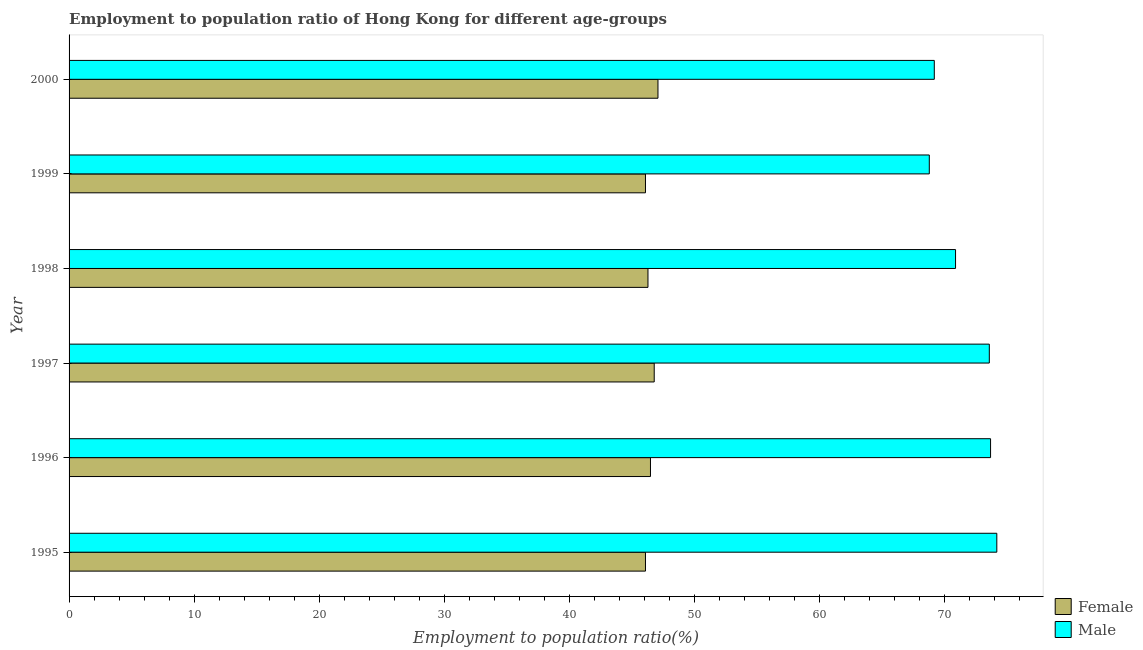How many different coloured bars are there?
Offer a very short reply. 2. How many groups of bars are there?
Keep it short and to the point. 6. Are the number of bars on each tick of the Y-axis equal?
Provide a short and direct response. Yes. How many bars are there on the 5th tick from the top?
Provide a succinct answer. 2. In how many cases, is the number of bars for a given year not equal to the number of legend labels?
Provide a succinct answer. 0. What is the employment to population ratio(female) in 1998?
Your response must be concise. 46.3. Across all years, what is the maximum employment to population ratio(male)?
Ensure brevity in your answer.  74.2. Across all years, what is the minimum employment to population ratio(female)?
Provide a short and direct response. 46.1. In which year was the employment to population ratio(female) maximum?
Provide a succinct answer. 2000. In which year was the employment to population ratio(female) minimum?
Make the answer very short. 1995. What is the total employment to population ratio(female) in the graph?
Keep it short and to the point. 278.9. What is the difference between the employment to population ratio(male) in 1997 and that in 1998?
Provide a short and direct response. 2.7. What is the difference between the employment to population ratio(male) in 1997 and the employment to population ratio(female) in 1996?
Make the answer very short. 27.1. What is the average employment to population ratio(female) per year?
Keep it short and to the point. 46.48. In the year 1998, what is the difference between the employment to population ratio(female) and employment to population ratio(male)?
Your answer should be compact. -24.6. Is the employment to population ratio(female) in 1998 less than that in 2000?
Your response must be concise. Yes. Is the difference between the employment to population ratio(female) in 1995 and 1998 greater than the difference between the employment to population ratio(male) in 1995 and 1998?
Your response must be concise. No. What is the difference between the highest and the second highest employment to population ratio(male)?
Your answer should be compact. 0.5. What is the difference between the highest and the lowest employment to population ratio(male)?
Provide a succinct answer. 5.4. Is the sum of the employment to population ratio(female) in 1996 and 2000 greater than the maximum employment to population ratio(male) across all years?
Offer a very short reply. Yes. What does the 1st bar from the top in 1997 represents?
Give a very brief answer. Male. Does the graph contain grids?
Make the answer very short. No. How are the legend labels stacked?
Keep it short and to the point. Vertical. What is the title of the graph?
Provide a short and direct response. Employment to population ratio of Hong Kong for different age-groups. What is the label or title of the X-axis?
Offer a terse response. Employment to population ratio(%). What is the Employment to population ratio(%) of Female in 1995?
Give a very brief answer. 46.1. What is the Employment to population ratio(%) in Male in 1995?
Your answer should be compact. 74.2. What is the Employment to population ratio(%) of Female in 1996?
Your response must be concise. 46.5. What is the Employment to population ratio(%) of Male in 1996?
Ensure brevity in your answer.  73.7. What is the Employment to population ratio(%) of Female in 1997?
Ensure brevity in your answer.  46.8. What is the Employment to population ratio(%) in Male in 1997?
Provide a succinct answer. 73.6. What is the Employment to population ratio(%) in Female in 1998?
Your response must be concise. 46.3. What is the Employment to population ratio(%) in Male in 1998?
Offer a very short reply. 70.9. What is the Employment to population ratio(%) in Female in 1999?
Ensure brevity in your answer.  46.1. What is the Employment to population ratio(%) of Male in 1999?
Provide a succinct answer. 68.8. What is the Employment to population ratio(%) in Female in 2000?
Provide a short and direct response. 47.1. What is the Employment to population ratio(%) in Male in 2000?
Offer a very short reply. 69.2. Across all years, what is the maximum Employment to population ratio(%) of Female?
Keep it short and to the point. 47.1. Across all years, what is the maximum Employment to population ratio(%) of Male?
Keep it short and to the point. 74.2. Across all years, what is the minimum Employment to population ratio(%) of Female?
Your answer should be compact. 46.1. Across all years, what is the minimum Employment to population ratio(%) in Male?
Make the answer very short. 68.8. What is the total Employment to population ratio(%) of Female in the graph?
Your answer should be very brief. 278.9. What is the total Employment to population ratio(%) in Male in the graph?
Your answer should be very brief. 430.4. What is the difference between the Employment to population ratio(%) in Male in 1995 and that in 1996?
Your answer should be compact. 0.5. What is the difference between the Employment to population ratio(%) of Female in 1995 and that in 1998?
Make the answer very short. -0.2. What is the difference between the Employment to population ratio(%) in Male in 1995 and that in 1998?
Make the answer very short. 3.3. What is the difference between the Employment to population ratio(%) of Female in 1995 and that in 1999?
Give a very brief answer. 0. What is the difference between the Employment to population ratio(%) in Male in 1995 and that in 1999?
Offer a terse response. 5.4. What is the difference between the Employment to population ratio(%) in Male in 1995 and that in 2000?
Offer a very short reply. 5. What is the difference between the Employment to population ratio(%) in Female in 1996 and that in 1997?
Provide a succinct answer. -0.3. What is the difference between the Employment to population ratio(%) in Male in 1996 and that in 1998?
Keep it short and to the point. 2.8. What is the difference between the Employment to population ratio(%) of Female in 1996 and that in 1999?
Offer a very short reply. 0.4. What is the difference between the Employment to population ratio(%) in Male in 1996 and that in 1999?
Offer a terse response. 4.9. What is the difference between the Employment to population ratio(%) in Female in 1997 and that in 1998?
Provide a short and direct response. 0.5. What is the difference between the Employment to population ratio(%) of Male in 1997 and that in 2000?
Provide a succinct answer. 4.4. What is the difference between the Employment to population ratio(%) of Female in 1998 and that in 1999?
Keep it short and to the point. 0.2. What is the difference between the Employment to population ratio(%) in Male in 1998 and that in 1999?
Give a very brief answer. 2.1. What is the difference between the Employment to population ratio(%) of Female in 1998 and that in 2000?
Keep it short and to the point. -0.8. What is the difference between the Employment to population ratio(%) in Female in 1999 and that in 2000?
Your answer should be very brief. -1. What is the difference between the Employment to population ratio(%) in Female in 1995 and the Employment to population ratio(%) in Male in 1996?
Provide a succinct answer. -27.6. What is the difference between the Employment to population ratio(%) of Female in 1995 and the Employment to population ratio(%) of Male in 1997?
Your response must be concise. -27.5. What is the difference between the Employment to population ratio(%) in Female in 1995 and the Employment to population ratio(%) in Male in 1998?
Provide a short and direct response. -24.8. What is the difference between the Employment to population ratio(%) in Female in 1995 and the Employment to population ratio(%) in Male in 1999?
Keep it short and to the point. -22.7. What is the difference between the Employment to population ratio(%) of Female in 1995 and the Employment to population ratio(%) of Male in 2000?
Give a very brief answer. -23.1. What is the difference between the Employment to population ratio(%) of Female in 1996 and the Employment to population ratio(%) of Male in 1997?
Give a very brief answer. -27.1. What is the difference between the Employment to population ratio(%) of Female in 1996 and the Employment to population ratio(%) of Male in 1998?
Provide a short and direct response. -24.4. What is the difference between the Employment to population ratio(%) of Female in 1996 and the Employment to population ratio(%) of Male in 1999?
Provide a succinct answer. -22.3. What is the difference between the Employment to population ratio(%) in Female in 1996 and the Employment to population ratio(%) in Male in 2000?
Your answer should be compact. -22.7. What is the difference between the Employment to population ratio(%) in Female in 1997 and the Employment to population ratio(%) in Male in 1998?
Give a very brief answer. -24.1. What is the difference between the Employment to population ratio(%) in Female in 1997 and the Employment to population ratio(%) in Male in 2000?
Ensure brevity in your answer.  -22.4. What is the difference between the Employment to population ratio(%) of Female in 1998 and the Employment to population ratio(%) of Male in 1999?
Provide a short and direct response. -22.5. What is the difference between the Employment to population ratio(%) of Female in 1998 and the Employment to population ratio(%) of Male in 2000?
Offer a terse response. -22.9. What is the difference between the Employment to population ratio(%) in Female in 1999 and the Employment to population ratio(%) in Male in 2000?
Your answer should be compact. -23.1. What is the average Employment to population ratio(%) in Female per year?
Offer a very short reply. 46.48. What is the average Employment to population ratio(%) of Male per year?
Provide a succinct answer. 71.73. In the year 1995, what is the difference between the Employment to population ratio(%) in Female and Employment to population ratio(%) in Male?
Your answer should be very brief. -28.1. In the year 1996, what is the difference between the Employment to population ratio(%) in Female and Employment to population ratio(%) in Male?
Your response must be concise. -27.2. In the year 1997, what is the difference between the Employment to population ratio(%) of Female and Employment to population ratio(%) of Male?
Ensure brevity in your answer.  -26.8. In the year 1998, what is the difference between the Employment to population ratio(%) of Female and Employment to population ratio(%) of Male?
Offer a very short reply. -24.6. In the year 1999, what is the difference between the Employment to population ratio(%) in Female and Employment to population ratio(%) in Male?
Provide a succinct answer. -22.7. In the year 2000, what is the difference between the Employment to population ratio(%) in Female and Employment to population ratio(%) in Male?
Provide a short and direct response. -22.1. What is the ratio of the Employment to population ratio(%) in Female in 1995 to that in 1996?
Ensure brevity in your answer.  0.99. What is the ratio of the Employment to population ratio(%) in Male in 1995 to that in 1996?
Provide a short and direct response. 1.01. What is the ratio of the Employment to population ratio(%) in Male in 1995 to that in 1997?
Ensure brevity in your answer.  1.01. What is the ratio of the Employment to population ratio(%) of Female in 1995 to that in 1998?
Provide a short and direct response. 1. What is the ratio of the Employment to population ratio(%) in Male in 1995 to that in 1998?
Offer a very short reply. 1.05. What is the ratio of the Employment to population ratio(%) of Female in 1995 to that in 1999?
Give a very brief answer. 1. What is the ratio of the Employment to population ratio(%) in Male in 1995 to that in 1999?
Your answer should be very brief. 1.08. What is the ratio of the Employment to population ratio(%) in Female in 1995 to that in 2000?
Keep it short and to the point. 0.98. What is the ratio of the Employment to population ratio(%) of Male in 1995 to that in 2000?
Offer a terse response. 1.07. What is the ratio of the Employment to population ratio(%) in Female in 1996 to that in 1997?
Offer a terse response. 0.99. What is the ratio of the Employment to population ratio(%) in Male in 1996 to that in 1997?
Keep it short and to the point. 1. What is the ratio of the Employment to population ratio(%) of Female in 1996 to that in 1998?
Ensure brevity in your answer.  1. What is the ratio of the Employment to population ratio(%) in Male in 1996 to that in 1998?
Offer a terse response. 1.04. What is the ratio of the Employment to population ratio(%) of Female in 1996 to that in 1999?
Ensure brevity in your answer.  1.01. What is the ratio of the Employment to population ratio(%) in Male in 1996 to that in 1999?
Ensure brevity in your answer.  1.07. What is the ratio of the Employment to population ratio(%) of Female in 1996 to that in 2000?
Offer a very short reply. 0.99. What is the ratio of the Employment to population ratio(%) in Male in 1996 to that in 2000?
Ensure brevity in your answer.  1.06. What is the ratio of the Employment to population ratio(%) in Female in 1997 to that in 1998?
Offer a very short reply. 1.01. What is the ratio of the Employment to population ratio(%) in Male in 1997 to that in 1998?
Offer a very short reply. 1.04. What is the ratio of the Employment to population ratio(%) in Female in 1997 to that in 1999?
Make the answer very short. 1.02. What is the ratio of the Employment to population ratio(%) of Male in 1997 to that in 1999?
Give a very brief answer. 1.07. What is the ratio of the Employment to population ratio(%) of Male in 1997 to that in 2000?
Your answer should be compact. 1.06. What is the ratio of the Employment to population ratio(%) in Male in 1998 to that in 1999?
Your response must be concise. 1.03. What is the ratio of the Employment to population ratio(%) of Male in 1998 to that in 2000?
Make the answer very short. 1.02. What is the ratio of the Employment to population ratio(%) in Female in 1999 to that in 2000?
Your answer should be very brief. 0.98. What is the ratio of the Employment to population ratio(%) of Male in 1999 to that in 2000?
Keep it short and to the point. 0.99. What is the difference between the highest and the second highest Employment to population ratio(%) in Male?
Your answer should be compact. 0.5. What is the difference between the highest and the lowest Employment to population ratio(%) of Male?
Give a very brief answer. 5.4. 